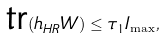<formula> <loc_0><loc_0><loc_500><loc_500>\text {tr} ( h _ { H R } W ) \leq \tau _ { 1 } I _ { \max } ,</formula> 